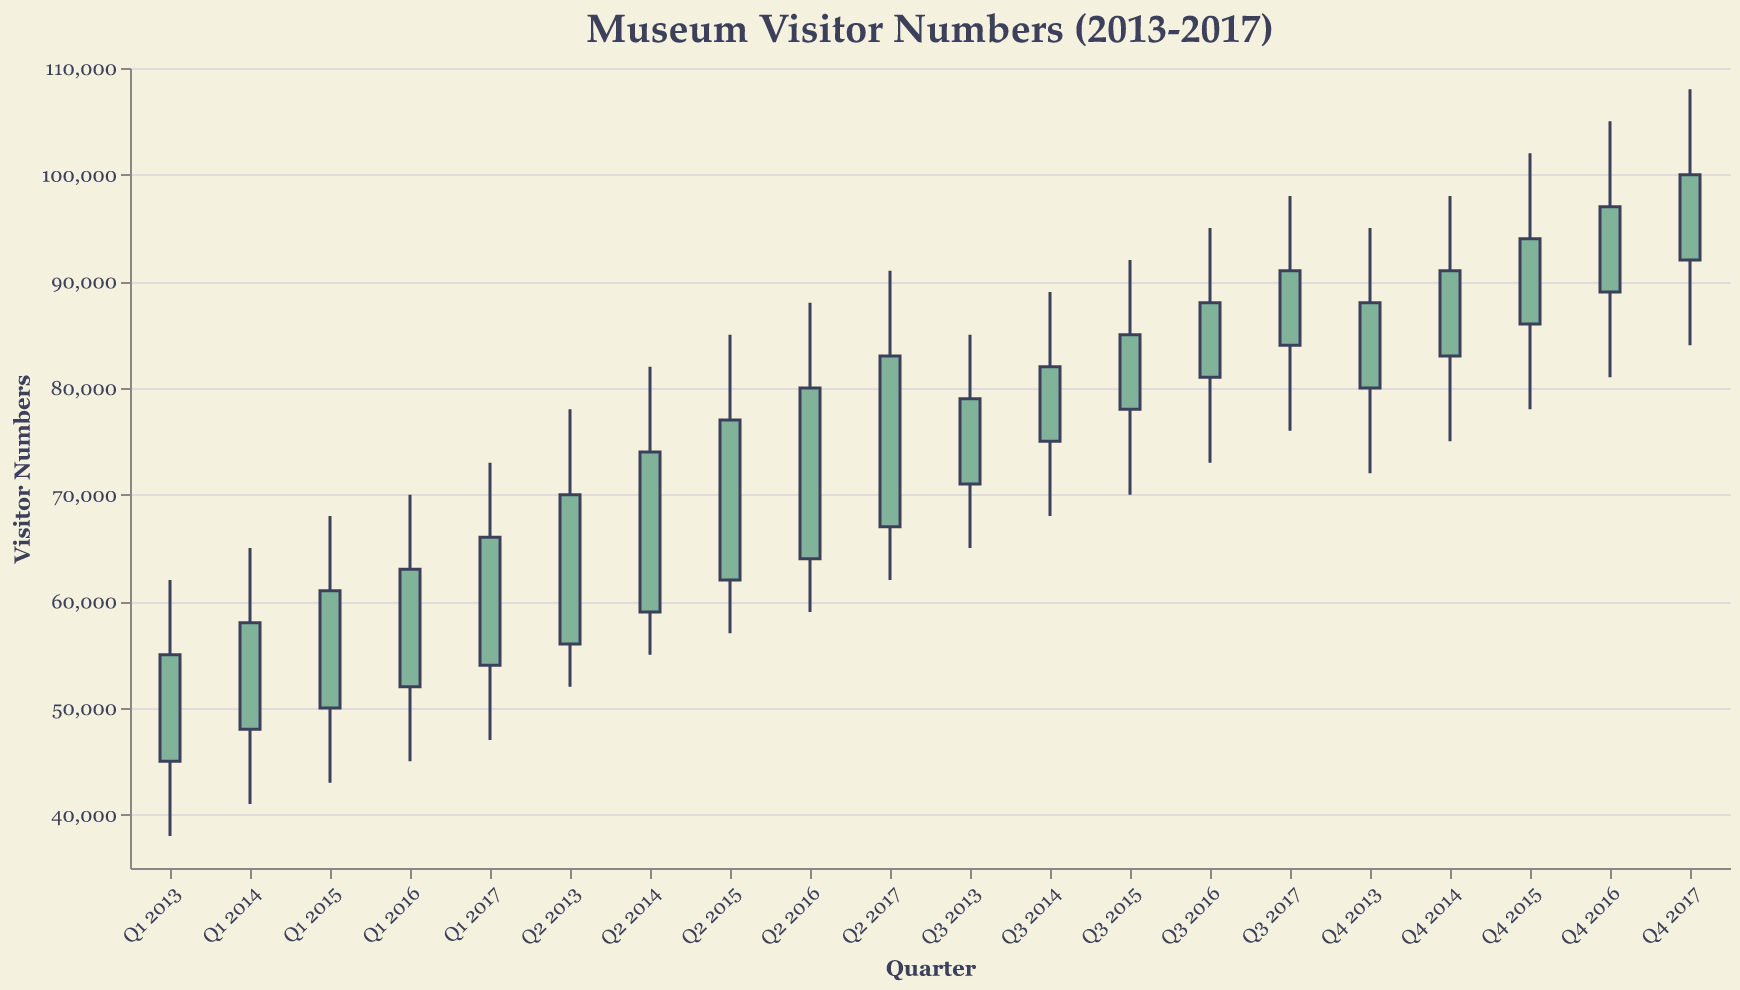What is the title of the chart? The title of the chart is located at the top of the figure and provides a concise description of the data being shown.
Answer: Museum Visitor Numbers (2013-2017) What is the highest point of visitor numbers in Q4 2017? The highest point can be found by identifying the peak attendance for Q4 2017 visually from the y-axis values.
Answer: 108,000 During which quarter did visitor numbers reach the lowest point, and what was that number? The lowest point is determined by finding the minimum value across the "Low" data for all quarters shown.
Answer: Q1 2013, 38,000 Compare the opening and closing visitor numbers for Q2 2015. Did they increase or decrease, and by how much? To determine if they increased or decreased: Opening (62,000) vs. Closing (77,000). Calculate the difference: 77,000 - 62,000 = 15,000, indicating an increase.
Answer: Increased by 15,000 What is the overall trend in museum visitor numbers from Q1 2013 to Q4 2017? Analyze the overall trend by observing the opening and closing values from Q1 2013 to Q4 2017. The opening value increases from 45,000 to 92,000 and the closing value from 55,000 to 100,000. Thus, the trend is upward.
Answer: Upward What was the peak visitor number in 2016, and in which quarter did it occur? Locate the highest "High" value within any quarter of 2016. Q4 2016 reaches 105,000 visitors, which is the highest in that year.
Answer: 105,000 in Q4 2016 Which year had the highest closing visitor numbers, and what was the value? Compare the closing values for the last quarter of each year. 2017 had the highest closing value in Q4 at 100,000.
Answer: 2017, 100,000 What is the average of the opening visitor numbers for the first quarter (Q1) of each year from 2013 to 2017? Calculate the average: (45,000 + 48,000 + 50,000 + 52,000 + 54,000) / 5 = 49,800.
Answer: 49,800 How many times did the closing visitor numbers exceed the opening visitor numbers from 2013 to 2017? Count the number of quarters where the closing value is greater than the opening value. This occurs in 13 out of 20 quarters.
Answer: 13 times During which year did the museum see the largest single quarterly increase in visitor numbers, and what was the increase? Determine the largest increase by comparing the difference between opening and closing for all quarters: Q4 2013 had the largest increase from 80,000 to 88,000, a difference of 8,000.
Answer: 2013, 8,000 